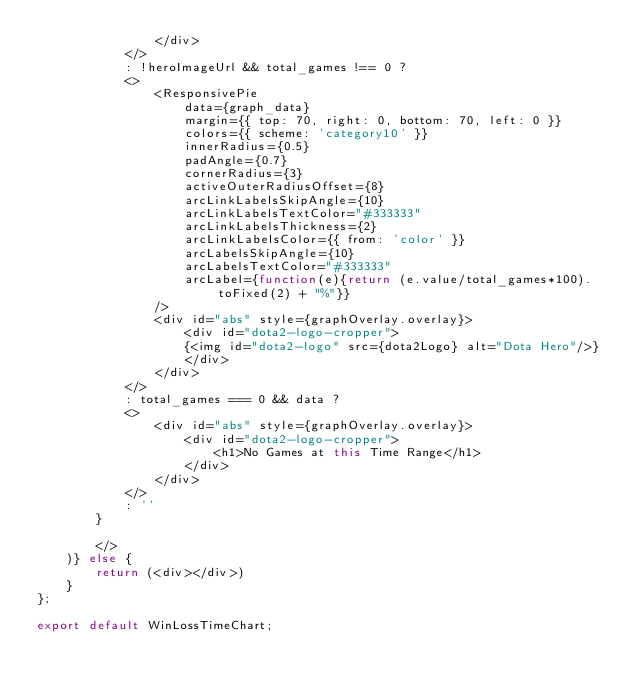Convert code to text. <code><loc_0><loc_0><loc_500><loc_500><_JavaScript_>                </div>
            </>
            : !heroImageUrl && total_games !== 0 ?
            <>
                <ResponsivePie
                    data={graph_data}
                    margin={{ top: 70, right: 0, bottom: 70, left: 0 }}
                    colors={{ scheme: 'category10' }}
                    innerRadius={0.5}
                    padAngle={0.7}
                    cornerRadius={3}
                    activeOuterRadiusOffset={8}
                    arcLinkLabelsSkipAngle={10}
                    arcLinkLabelsTextColor="#333333"
                    arcLinkLabelsThickness={2}
                    arcLinkLabelsColor={{ from: 'color' }}
                    arcLabelsSkipAngle={10}
                    arcLabelsTextColor="#333333"
                    arcLabel={function(e){return (e.value/total_games*100).toFixed(2) + "%"}}
                />
                <div id="abs" style={graphOverlay.overlay}>
                    <div id="dota2-logo-cropper">
                    {<img id="dota2-logo" src={dota2Logo} alt="Dota Hero"/>}
                    </div>
                </div>
            </>
            : total_games === 0 && data ?
            <>
                <div id="abs" style={graphOverlay.overlay}>
                    <div id="dota2-logo-cropper">
                        <h1>No Games at this Time Range</h1>
                    </div>
                </div>
            </>
            : ''
        }

        </>              
    )} else {
        return (<div></div>)
    }
};
   
export default WinLossTimeChart;</code> 